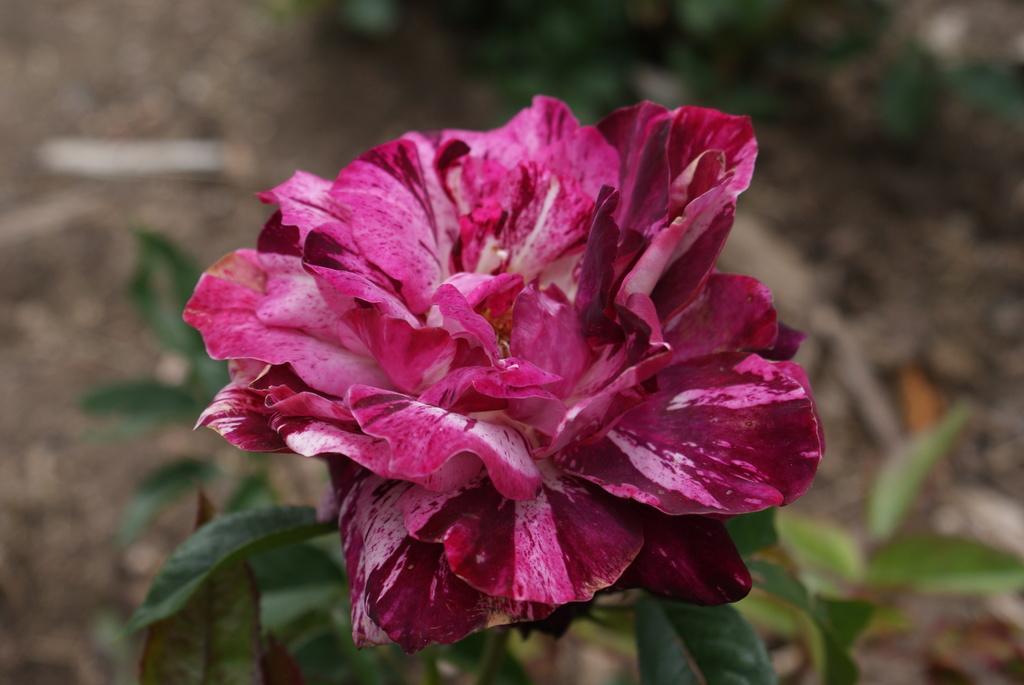Please provide a concise description of this image. In this image we can see one flower and two plants on the surface. 